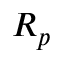Convert formula to latex. <formula><loc_0><loc_0><loc_500><loc_500>R _ { p }</formula> 